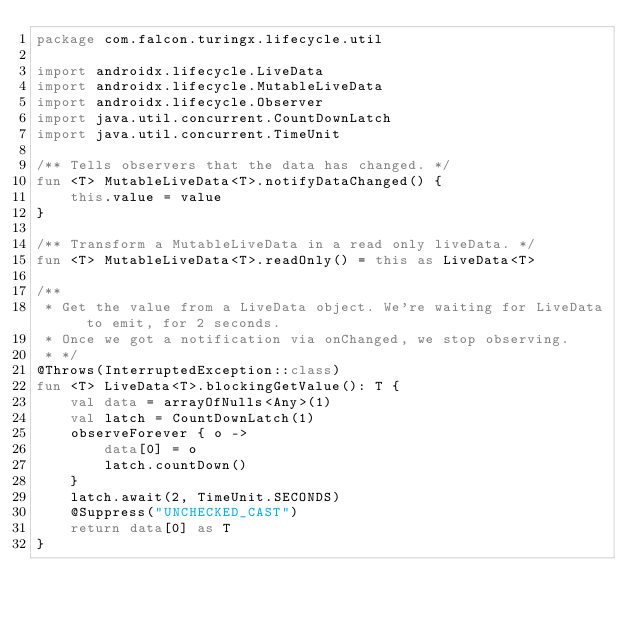<code> <loc_0><loc_0><loc_500><loc_500><_Kotlin_>package com.falcon.turingx.lifecycle.util

import androidx.lifecycle.LiveData
import androidx.lifecycle.MutableLiveData
import androidx.lifecycle.Observer
import java.util.concurrent.CountDownLatch
import java.util.concurrent.TimeUnit

/** Tells observers that the data has changed. */
fun <T> MutableLiveData<T>.notifyDataChanged() {
    this.value = value
}

/** Transform a MutableLiveData in a read only liveData. */
fun <T> MutableLiveData<T>.readOnly() = this as LiveData<T>

/**
 * Get the value from a LiveData object. We're waiting for LiveData to emit, for 2 seconds.
 * Once we got a notification via onChanged, we stop observing.
 * */
@Throws(InterruptedException::class)
fun <T> LiveData<T>.blockingGetValue(): T {
    val data = arrayOfNulls<Any>(1)
    val latch = CountDownLatch(1)
    observeForever { o ->
        data[0] = o
        latch.countDown()
    }
    latch.await(2, TimeUnit.SECONDS)
    @Suppress("UNCHECKED_CAST")
    return data[0] as T
}</code> 